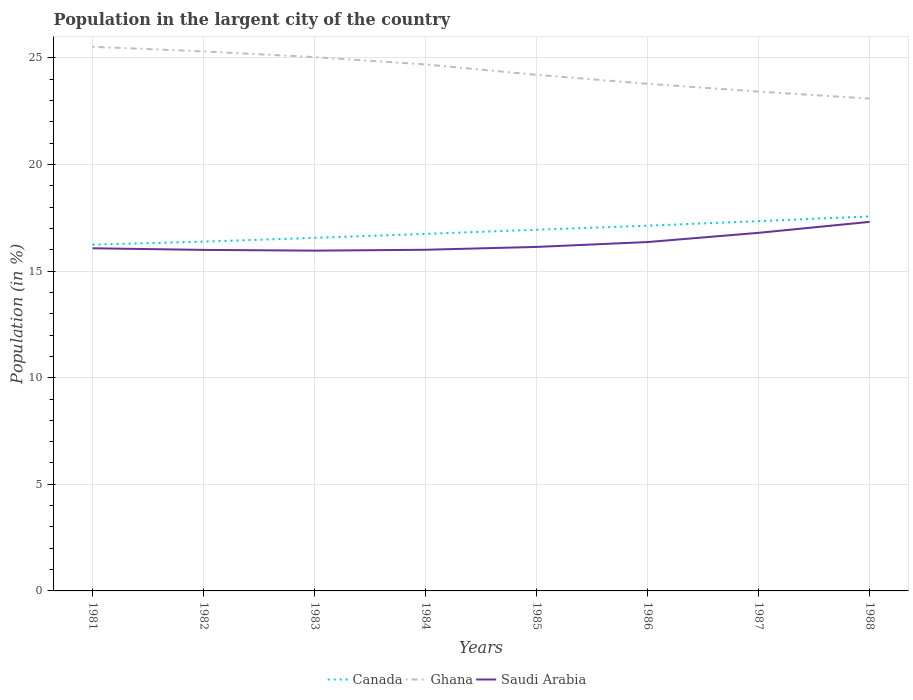Does the line corresponding to Ghana intersect with the line corresponding to Saudi Arabia?
Keep it short and to the point. No. Across all years, what is the maximum percentage of population in the largent city in Canada?
Provide a succinct answer. 16.24. In which year was the percentage of population in the largent city in Saudi Arabia maximum?
Offer a terse response. 1983. What is the total percentage of population in the largent city in Saudi Arabia in the graph?
Provide a short and direct response. -0.17. What is the difference between the highest and the second highest percentage of population in the largent city in Ghana?
Make the answer very short. 2.43. How many lines are there?
Your answer should be very brief. 3. How many years are there in the graph?
Ensure brevity in your answer.  8. What is the difference between two consecutive major ticks on the Y-axis?
Provide a short and direct response. 5. Where does the legend appear in the graph?
Offer a terse response. Bottom center. How are the legend labels stacked?
Offer a terse response. Horizontal. What is the title of the graph?
Offer a terse response. Population in the largent city of the country. Does "Haiti" appear as one of the legend labels in the graph?
Your answer should be compact. No. What is the Population (in %) of Canada in 1981?
Your response must be concise. 16.24. What is the Population (in %) of Ghana in 1981?
Offer a very short reply. 25.52. What is the Population (in %) of Saudi Arabia in 1981?
Offer a terse response. 16.07. What is the Population (in %) of Canada in 1982?
Make the answer very short. 16.38. What is the Population (in %) of Ghana in 1982?
Your answer should be very brief. 25.3. What is the Population (in %) of Saudi Arabia in 1982?
Your answer should be compact. 16. What is the Population (in %) of Canada in 1983?
Make the answer very short. 16.56. What is the Population (in %) in Ghana in 1983?
Provide a short and direct response. 25.04. What is the Population (in %) in Saudi Arabia in 1983?
Your answer should be compact. 15.96. What is the Population (in %) in Canada in 1984?
Your answer should be compact. 16.75. What is the Population (in %) of Ghana in 1984?
Provide a succinct answer. 24.69. What is the Population (in %) of Saudi Arabia in 1984?
Give a very brief answer. 16. What is the Population (in %) of Canada in 1985?
Give a very brief answer. 16.94. What is the Population (in %) of Ghana in 1985?
Your answer should be compact. 24.2. What is the Population (in %) in Saudi Arabia in 1985?
Your answer should be very brief. 16.13. What is the Population (in %) in Canada in 1986?
Offer a terse response. 17.13. What is the Population (in %) of Ghana in 1986?
Give a very brief answer. 23.79. What is the Population (in %) of Saudi Arabia in 1986?
Your response must be concise. 16.36. What is the Population (in %) of Canada in 1987?
Provide a succinct answer. 17.34. What is the Population (in %) in Ghana in 1987?
Your answer should be compact. 23.42. What is the Population (in %) of Saudi Arabia in 1987?
Offer a terse response. 16.8. What is the Population (in %) of Canada in 1988?
Your answer should be compact. 17.56. What is the Population (in %) in Ghana in 1988?
Your answer should be compact. 23.09. What is the Population (in %) in Saudi Arabia in 1988?
Make the answer very short. 17.31. Across all years, what is the maximum Population (in %) of Canada?
Give a very brief answer. 17.56. Across all years, what is the maximum Population (in %) of Ghana?
Offer a very short reply. 25.52. Across all years, what is the maximum Population (in %) of Saudi Arabia?
Your answer should be compact. 17.31. Across all years, what is the minimum Population (in %) in Canada?
Your response must be concise. 16.24. Across all years, what is the minimum Population (in %) in Ghana?
Provide a short and direct response. 23.09. Across all years, what is the minimum Population (in %) in Saudi Arabia?
Offer a terse response. 15.96. What is the total Population (in %) of Canada in the graph?
Offer a terse response. 134.91. What is the total Population (in %) of Ghana in the graph?
Provide a succinct answer. 195.06. What is the total Population (in %) of Saudi Arabia in the graph?
Keep it short and to the point. 130.63. What is the difference between the Population (in %) of Canada in 1981 and that in 1982?
Provide a succinct answer. -0.14. What is the difference between the Population (in %) in Ghana in 1981 and that in 1982?
Ensure brevity in your answer.  0.22. What is the difference between the Population (in %) of Saudi Arabia in 1981 and that in 1982?
Your answer should be very brief. 0.08. What is the difference between the Population (in %) in Canada in 1981 and that in 1983?
Provide a short and direct response. -0.32. What is the difference between the Population (in %) in Ghana in 1981 and that in 1983?
Your response must be concise. 0.49. What is the difference between the Population (in %) of Saudi Arabia in 1981 and that in 1983?
Give a very brief answer. 0.11. What is the difference between the Population (in %) in Canada in 1981 and that in 1984?
Offer a terse response. -0.51. What is the difference between the Population (in %) in Ghana in 1981 and that in 1984?
Make the answer very short. 0.83. What is the difference between the Population (in %) in Saudi Arabia in 1981 and that in 1984?
Provide a short and direct response. 0.07. What is the difference between the Population (in %) of Canada in 1981 and that in 1985?
Provide a succinct answer. -0.7. What is the difference between the Population (in %) in Ghana in 1981 and that in 1985?
Ensure brevity in your answer.  1.32. What is the difference between the Population (in %) of Saudi Arabia in 1981 and that in 1985?
Ensure brevity in your answer.  -0.06. What is the difference between the Population (in %) in Canada in 1981 and that in 1986?
Provide a succinct answer. -0.89. What is the difference between the Population (in %) of Ghana in 1981 and that in 1986?
Offer a terse response. 1.74. What is the difference between the Population (in %) in Saudi Arabia in 1981 and that in 1986?
Your answer should be compact. -0.29. What is the difference between the Population (in %) in Canada in 1981 and that in 1987?
Ensure brevity in your answer.  -1.1. What is the difference between the Population (in %) of Ghana in 1981 and that in 1987?
Keep it short and to the point. 2.1. What is the difference between the Population (in %) in Saudi Arabia in 1981 and that in 1987?
Ensure brevity in your answer.  -0.72. What is the difference between the Population (in %) of Canada in 1981 and that in 1988?
Your answer should be very brief. -1.32. What is the difference between the Population (in %) of Ghana in 1981 and that in 1988?
Your answer should be very brief. 2.43. What is the difference between the Population (in %) of Saudi Arabia in 1981 and that in 1988?
Give a very brief answer. -1.24. What is the difference between the Population (in %) in Canada in 1982 and that in 1983?
Keep it short and to the point. -0.18. What is the difference between the Population (in %) in Ghana in 1982 and that in 1983?
Provide a short and direct response. 0.27. What is the difference between the Population (in %) of Saudi Arabia in 1982 and that in 1983?
Your answer should be very brief. 0.04. What is the difference between the Population (in %) in Canada in 1982 and that in 1984?
Your response must be concise. -0.36. What is the difference between the Population (in %) of Ghana in 1982 and that in 1984?
Your answer should be compact. 0.61. What is the difference between the Population (in %) of Saudi Arabia in 1982 and that in 1984?
Your response must be concise. -0.01. What is the difference between the Population (in %) of Canada in 1982 and that in 1985?
Your response must be concise. -0.56. What is the difference between the Population (in %) in Ghana in 1982 and that in 1985?
Provide a short and direct response. 1.1. What is the difference between the Population (in %) in Saudi Arabia in 1982 and that in 1985?
Ensure brevity in your answer.  -0.14. What is the difference between the Population (in %) in Canada in 1982 and that in 1986?
Provide a short and direct response. -0.75. What is the difference between the Population (in %) in Ghana in 1982 and that in 1986?
Your response must be concise. 1.52. What is the difference between the Population (in %) of Saudi Arabia in 1982 and that in 1986?
Provide a succinct answer. -0.37. What is the difference between the Population (in %) in Canada in 1982 and that in 1987?
Provide a short and direct response. -0.96. What is the difference between the Population (in %) in Ghana in 1982 and that in 1987?
Provide a succinct answer. 1.88. What is the difference between the Population (in %) of Saudi Arabia in 1982 and that in 1987?
Keep it short and to the point. -0.8. What is the difference between the Population (in %) in Canada in 1982 and that in 1988?
Provide a succinct answer. -1.18. What is the difference between the Population (in %) in Ghana in 1982 and that in 1988?
Keep it short and to the point. 2.21. What is the difference between the Population (in %) of Saudi Arabia in 1982 and that in 1988?
Your answer should be very brief. -1.31. What is the difference between the Population (in %) of Canada in 1983 and that in 1984?
Give a very brief answer. -0.19. What is the difference between the Population (in %) of Ghana in 1983 and that in 1984?
Your response must be concise. 0.34. What is the difference between the Population (in %) of Saudi Arabia in 1983 and that in 1984?
Keep it short and to the point. -0.04. What is the difference between the Population (in %) in Canada in 1983 and that in 1985?
Provide a short and direct response. -0.38. What is the difference between the Population (in %) in Ghana in 1983 and that in 1985?
Offer a very short reply. 0.83. What is the difference between the Population (in %) in Saudi Arabia in 1983 and that in 1985?
Offer a terse response. -0.17. What is the difference between the Population (in %) of Canada in 1983 and that in 1986?
Provide a short and direct response. -0.57. What is the difference between the Population (in %) in Ghana in 1983 and that in 1986?
Provide a succinct answer. 1.25. What is the difference between the Population (in %) of Saudi Arabia in 1983 and that in 1986?
Offer a terse response. -0.4. What is the difference between the Population (in %) in Canada in 1983 and that in 1987?
Give a very brief answer. -0.78. What is the difference between the Population (in %) of Ghana in 1983 and that in 1987?
Your response must be concise. 1.62. What is the difference between the Population (in %) of Saudi Arabia in 1983 and that in 1987?
Ensure brevity in your answer.  -0.84. What is the difference between the Population (in %) in Canada in 1983 and that in 1988?
Ensure brevity in your answer.  -1. What is the difference between the Population (in %) of Ghana in 1983 and that in 1988?
Offer a terse response. 1.95. What is the difference between the Population (in %) of Saudi Arabia in 1983 and that in 1988?
Offer a very short reply. -1.35. What is the difference between the Population (in %) in Canada in 1984 and that in 1985?
Provide a short and direct response. -0.19. What is the difference between the Population (in %) in Ghana in 1984 and that in 1985?
Give a very brief answer. 0.49. What is the difference between the Population (in %) of Saudi Arabia in 1984 and that in 1985?
Your answer should be very brief. -0.13. What is the difference between the Population (in %) in Canada in 1984 and that in 1986?
Offer a very short reply. -0.38. What is the difference between the Population (in %) in Ghana in 1984 and that in 1986?
Offer a very short reply. 0.91. What is the difference between the Population (in %) of Saudi Arabia in 1984 and that in 1986?
Provide a short and direct response. -0.36. What is the difference between the Population (in %) in Canada in 1984 and that in 1987?
Your answer should be compact. -0.6. What is the difference between the Population (in %) in Ghana in 1984 and that in 1987?
Make the answer very short. 1.27. What is the difference between the Population (in %) of Saudi Arabia in 1984 and that in 1987?
Provide a succinct answer. -0.79. What is the difference between the Population (in %) of Canada in 1984 and that in 1988?
Ensure brevity in your answer.  -0.82. What is the difference between the Population (in %) in Ghana in 1984 and that in 1988?
Your answer should be compact. 1.6. What is the difference between the Population (in %) of Saudi Arabia in 1984 and that in 1988?
Provide a succinct answer. -1.31. What is the difference between the Population (in %) of Canada in 1985 and that in 1986?
Your response must be concise. -0.19. What is the difference between the Population (in %) of Ghana in 1985 and that in 1986?
Your answer should be compact. 0.42. What is the difference between the Population (in %) of Saudi Arabia in 1985 and that in 1986?
Make the answer very short. -0.23. What is the difference between the Population (in %) in Canada in 1985 and that in 1987?
Make the answer very short. -0.4. What is the difference between the Population (in %) of Ghana in 1985 and that in 1987?
Your answer should be compact. 0.78. What is the difference between the Population (in %) of Saudi Arabia in 1985 and that in 1987?
Offer a terse response. -0.66. What is the difference between the Population (in %) of Canada in 1985 and that in 1988?
Your response must be concise. -0.62. What is the difference between the Population (in %) of Ghana in 1985 and that in 1988?
Offer a very short reply. 1.11. What is the difference between the Population (in %) in Saudi Arabia in 1985 and that in 1988?
Offer a terse response. -1.18. What is the difference between the Population (in %) in Canada in 1986 and that in 1987?
Offer a terse response. -0.21. What is the difference between the Population (in %) in Ghana in 1986 and that in 1987?
Make the answer very short. 0.37. What is the difference between the Population (in %) of Saudi Arabia in 1986 and that in 1987?
Keep it short and to the point. -0.43. What is the difference between the Population (in %) in Canada in 1986 and that in 1988?
Your answer should be compact. -0.43. What is the difference between the Population (in %) in Ghana in 1986 and that in 1988?
Keep it short and to the point. 0.7. What is the difference between the Population (in %) of Saudi Arabia in 1986 and that in 1988?
Your response must be concise. -0.95. What is the difference between the Population (in %) of Canada in 1987 and that in 1988?
Give a very brief answer. -0.22. What is the difference between the Population (in %) in Ghana in 1987 and that in 1988?
Provide a short and direct response. 0.33. What is the difference between the Population (in %) in Saudi Arabia in 1987 and that in 1988?
Your answer should be compact. -0.51. What is the difference between the Population (in %) of Canada in 1981 and the Population (in %) of Ghana in 1982?
Your response must be concise. -9.06. What is the difference between the Population (in %) of Canada in 1981 and the Population (in %) of Saudi Arabia in 1982?
Provide a short and direct response. 0.25. What is the difference between the Population (in %) in Ghana in 1981 and the Population (in %) in Saudi Arabia in 1982?
Give a very brief answer. 9.53. What is the difference between the Population (in %) in Canada in 1981 and the Population (in %) in Ghana in 1983?
Offer a very short reply. -8.8. What is the difference between the Population (in %) of Canada in 1981 and the Population (in %) of Saudi Arabia in 1983?
Make the answer very short. 0.28. What is the difference between the Population (in %) of Ghana in 1981 and the Population (in %) of Saudi Arabia in 1983?
Keep it short and to the point. 9.56. What is the difference between the Population (in %) of Canada in 1981 and the Population (in %) of Ghana in 1984?
Your response must be concise. -8.45. What is the difference between the Population (in %) of Canada in 1981 and the Population (in %) of Saudi Arabia in 1984?
Ensure brevity in your answer.  0.24. What is the difference between the Population (in %) of Ghana in 1981 and the Population (in %) of Saudi Arabia in 1984?
Give a very brief answer. 9.52. What is the difference between the Population (in %) of Canada in 1981 and the Population (in %) of Ghana in 1985?
Offer a terse response. -7.96. What is the difference between the Population (in %) in Canada in 1981 and the Population (in %) in Saudi Arabia in 1985?
Offer a very short reply. 0.11. What is the difference between the Population (in %) of Ghana in 1981 and the Population (in %) of Saudi Arabia in 1985?
Make the answer very short. 9.39. What is the difference between the Population (in %) of Canada in 1981 and the Population (in %) of Ghana in 1986?
Provide a succinct answer. -7.55. What is the difference between the Population (in %) of Canada in 1981 and the Population (in %) of Saudi Arabia in 1986?
Provide a short and direct response. -0.12. What is the difference between the Population (in %) in Ghana in 1981 and the Population (in %) in Saudi Arabia in 1986?
Ensure brevity in your answer.  9.16. What is the difference between the Population (in %) of Canada in 1981 and the Population (in %) of Ghana in 1987?
Give a very brief answer. -7.18. What is the difference between the Population (in %) in Canada in 1981 and the Population (in %) in Saudi Arabia in 1987?
Your answer should be very brief. -0.55. What is the difference between the Population (in %) in Ghana in 1981 and the Population (in %) in Saudi Arabia in 1987?
Your answer should be compact. 8.73. What is the difference between the Population (in %) of Canada in 1981 and the Population (in %) of Ghana in 1988?
Provide a short and direct response. -6.85. What is the difference between the Population (in %) of Canada in 1981 and the Population (in %) of Saudi Arabia in 1988?
Make the answer very short. -1.07. What is the difference between the Population (in %) in Ghana in 1981 and the Population (in %) in Saudi Arabia in 1988?
Offer a very short reply. 8.21. What is the difference between the Population (in %) in Canada in 1982 and the Population (in %) in Ghana in 1983?
Your response must be concise. -8.65. What is the difference between the Population (in %) in Canada in 1982 and the Population (in %) in Saudi Arabia in 1983?
Your response must be concise. 0.42. What is the difference between the Population (in %) of Ghana in 1982 and the Population (in %) of Saudi Arabia in 1983?
Your answer should be compact. 9.34. What is the difference between the Population (in %) of Canada in 1982 and the Population (in %) of Ghana in 1984?
Offer a very short reply. -8.31. What is the difference between the Population (in %) in Canada in 1982 and the Population (in %) in Saudi Arabia in 1984?
Your answer should be compact. 0.38. What is the difference between the Population (in %) in Ghana in 1982 and the Population (in %) in Saudi Arabia in 1984?
Offer a terse response. 9.3. What is the difference between the Population (in %) of Canada in 1982 and the Population (in %) of Ghana in 1985?
Ensure brevity in your answer.  -7.82. What is the difference between the Population (in %) of Canada in 1982 and the Population (in %) of Saudi Arabia in 1985?
Provide a succinct answer. 0.25. What is the difference between the Population (in %) in Ghana in 1982 and the Population (in %) in Saudi Arabia in 1985?
Your response must be concise. 9.17. What is the difference between the Population (in %) in Canada in 1982 and the Population (in %) in Ghana in 1986?
Ensure brevity in your answer.  -7.4. What is the difference between the Population (in %) in Ghana in 1982 and the Population (in %) in Saudi Arabia in 1986?
Make the answer very short. 8.94. What is the difference between the Population (in %) of Canada in 1982 and the Population (in %) of Ghana in 1987?
Provide a short and direct response. -7.04. What is the difference between the Population (in %) in Canada in 1982 and the Population (in %) in Saudi Arabia in 1987?
Give a very brief answer. -0.41. What is the difference between the Population (in %) of Ghana in 1982 and the Population (in %) of Saudi Arabia in 1987?
Give a very brief answer. 8.51. What is the difference between the Population (in %) of Canada in 1982 and the Population (in %) of Ghana in 1988?
Provide a succinct answer. -6.71. What is the difference between the Population (in %) in Canada in 1982 and the Population (in %) in Saudi Arabia in 1988?
Provide a succinct answer. -0.93. What is the difference between the Population (in %) in Ghana in 1982 and the Population (in %) in Saudi Arabia in 1988?
Make the answer very short. 7.99. What is the difference between the Population (in %) of Canada in 1983 and the Population (in %) of Ghana in 1984?
Offer a terse response. -8.13. What is the difference between the Population (in %) in Canada in 1983 and the Population (in %) in Saudi Arabia in 1984?
Your response must be concise. 0.56. What is the difference between the Population (in %) of Ghana in 1983 and the Population (in %) of Saudi Arabia in 1984?
Provide a succinct answer. 9.03. What is the difference between the Population (in %) of Canada in 1983 and the Population (in %) of Ghana in 1985?
Provide a short and direct response. -7.64. What is the difference between the Population (in %) of Canada in 1983 and the Population (in %) of Saudi Arabia in 1985?
Keep it short and to the point. 0.43. What is the difference between the Population (in %) of Ghana in 1983 and the Population (in %) of Saudi Arabia in 1985?
Make the answer very short. 8.9. What is the difference between the Population (in %) of Canada in 1983 and the Population (in %) of Ghana in 1986?
Your answer should be very brief. -7.23. What is the difference between the Population (in %) of Canada in 1983 and the Population (in %) of Saudi Arabia in 1986?
Offer a very short reply. 0.2. What is the difference between the Population (in %) of Ghana in 1983 and the Population (in %) of Saudi Arabia in 1986?
Ensure brevity in your answer.  8.67. What is the difference between the Population (in %) of Canada in 1983 and the Population (in %) of Ghana in 1987?
Your response must be concise. -6.86. What is the difference between the Population (in %) in Canada in 1983 and the Population (in %) in Saudi Arabia in 1987?
Your answer should be compact. -0.24. What is the difference between the Population (in %) in Ghana in 1983 and the Population (in %) in Saudi Arabia in 1987?
Your response must be concise. 8.24. What is the difference between the Population (in %) of Canada in 1983 and the Population (in %) of Ghana in 1988?
Keep it short and to the point. -6.53. What is the difference between the Population (in %) in Canada in 1983 and the Population (in %) in Saudi Arabia in 1988?
Your response must be concise. -0.75. What is the difference between the Population (in %) of Ghana in 1983 and the Population (in %) of Saudi Arabia in 1988?
Your answer should be very brief. 7.73. What is the difference between the Population (in %) in Canada in 1984 and the Population (in %) in Ghana in 1985?
Make the answer very short. -7.46. What is the difference between the Population (in %) of Canada in 1984 and the Population (in %) of Saudi Arabia in 1985?
Offer a very short reply. 0.61. What is the difference between the Population (in %) in Ghana in 1984 and the Population (in %) in Saudi Arabia in 1985?
Provide a short and direct response. 8.56. What is the difference between the Population (in %) in Canada in 1984 and the Population (in %) in Ghana in 1986?
Provide a succinct answer. -7.04. What is the difference between the Population (in %) of Canada in 1984 and the Population (in %) of Saudi Arabia in 1986?
Provide a succinct answer. 0.38. What is the difference between the Population (in %) in Ghana in 1984 and the Population (in %) in Saudi Arabia in 1986?
Offer a terse response. 8.33. What is the difference between the Population (in %) of Canada in 1984 and the Population (in %) of Ghana in 1987?
Provide a short and direct response. -6.67. What is the difference between the Population (in %) in Canada in 1984 and the Population (in %) in Saudi Arabia in 1987?
Make the answer very short. -0.05. What is the difference between the Population (in %) in Ghana in 1984 and the Population (in %) in Saudi Arabia in 1987?
Ensure brevity in your answer.  7.9. What is the difference between the Population (in %) in Canada in 1984 and the Population (in %) in Ghana in 1988?
Make the answer very short. -6.34. What is the difference between the Population (in %) in Canada in 1984 and the Population (in %) in Saudi Arabia in 1988?
Your answer should be compact. -0.56. What is the difference between the Population (in %) in Ghana in 1984 and the Population (in %) in Saudi Arabia in 1988?
Offer a very short reply. 7.38. What is the difference between the Population (in %) in Canada in 1985 and the Population (in %) in Ghana in 1986?
Offer a terse response. -6.85. What is the difference between the Population (in %) in Canada in 1985 and the Population (in %) in Saudi Arabia in 1986?
Provide a succinct answer. 0.58. What is the difference between the Population (in %) of Ghana in 1985 and the Population (in %) of Saudi Arabia in 1986?
Provide a succinct answer. 7.84. What is the difference between the Population (in %) of Canada in 1985 and the Population (in %) of Ghana in 1987?
Provide a short and direct response. -6.48. What is the difference between the Population (in %) in Canada in 1985 and the Population (in %) in Saudi Arabia in 1987?
Your answer should be very brief. 0.14. What is the difference between the Population (in %) of Ghana in 1985 and the Population (in %) of Saudi Arabia in 1987?
Offer a very short reply. 7.41. What is the difference between the Population (in %) in Canada in 1985 and the Population (in %) in Ghana in 1988?
Provide a short and direct response. -6.15. What is the difference between the Population (in %) in Canada in 1985 and the Population (in %) in Saudi Arabia in 1988?
Provide a short and direct response. -0.37. What is the difference between the Population (in %) in Ghana in 1985 and the Population (in %) in Saudi Arabia in 1988?
Offer a very short reply. 6.89. What is the difference between the Population (in %) in Canada in 1986 and the Population (in %) in Ghana in 1987?
Your answer should be compact. -6.29. What is the difference between the Population (in %) of Canada in 1986 and the Population (in %) of Saudi Arabia in 1987?
Make the answer very short. 0.33. What is the difference between the Population (in %) of Ghana in 1986 and the Population (in %) of Saudi Arabia in 1987?
Offer a terse response. 6.99. What is the difference between the Population (in %) in Canada in 1986 and the Population (in %) in Ghana in 1988?
Offer a very short reply. -5.96. What is the difference between the Population (in %) in Canada in 1986 and the Population (in %) in Saudi Arabia in 1988?
Give a very brief answer. -0.18. What is the difference between the Population (in %) of Ghana in 1986 and the Population (in %) of Saudi Arabia in 1988?
Ensure brevity in your answer.  6.48. What is the difference between the Population (in %) of Canada in 1987 and the Population (in %) of Ghana in 1988?
Keep it short and to the point. -5.75. What is the difference between the Population (in %) in Canada in 1987 and the Population (in %) in Saudi Arabia in 1988?
Offer a terse response. 0.03. What is the difference between the Population (in %) of Ghana in 1987 and the Population (in %) of Saudi Arabia in 1988?
Ensure brevity in your answer.  6.11. What is the average Population (in %) in Canada per year?
Your response must be concise. 16.86. What is the average Population (in %) in Ghana per year?
Your answer should be compact. 24.38. What is the average Population (in %) in Saudi Arabia per year?
Give a very brief answer. 16.33. In the year 1981, what is the difference between the Population (in %) in Canada and Population (in %) in Ghana?
Offer a very short reply. -9.28. In the year 1981, what is the difference between the Population (in %) in Canada and Population (in %) in Saudi Arabia?
Make the answer very short. 0.17. In the year 1981, what is the difference between the Population (in %) of Ghana and Population (in %) of Saudi Arabia?
Keep it short and to the point. 9.45. In the year 1982, what is the difference between the Population (in %) of Canada and Population (in %) of Ghana?
Make the answer very short. -8.92. In the year 1982, what is the difference between the Population (in %) of Canada and Population (in %) of Saudi Arabia?
Offer a terse response. 0.39. In the year 1982, what is the difference between the Population (in %) in Ghana and Population (in %) in Saudi Arabia?
Provide a succinct answer. 9.31. In the year 1983, what is the difference between the Population (in %) in Canada and Population (in %) in Ghana?
Keep it short and to the point. -8.48. In the year 1983, what is the difference between the Population (in %) in Canada and Population (in %) in Saudi Arabia?
Provide a succinct answer. 0.6. In the year 1983, what is the difference between the Population (in %) of Ghana and Population (in %) of Saudi Arabia?
Your answer should be compact. 9.08. In the year 1984, what is the difference between the Population (in %) of Canada and Population (in %) of Ghana?
Give a very brief answer. -7.95. In the year 1984, what is the difference between the Population (in %) in Canada and Population (in %) in Saudi Arabia?
Give a very brief answer. 0.75. In the year 1984, what is the difference between the Population (in %) of Ghana and Population (in %) of Saudi Arabia?
Provide a short and direct response. 8.69. In the year 1985, what is the difference between the Population (in %) of Canada and Population (in %) of Ghana?
Offer a terse response. -7.26. In the year 1985, what is the difference between the Population (in %) of Canada and Population (in %) of Saudi Arabia?
Your response must be concise. 0.81. In the year 1985, what is the difference between the Population (in %) in Ghana and Population (in %) in Saudi Arabia?
Give a very brief answer. 8.07. In the year 1986, what is the difference between the Population (in %) of Canada and Population (in %) of Ghana?
Give a very brief answer. -6.66. In the year 1986, what is the difference between the Population (in %) of Canada and Population (in %) of Saudi Arabia?
Your response must be concise. 0.77. In the year 1986, what is the difference between the Population (in %) in Ghana and Population (in %) in Saudi Arabia?
Give a very brief answer. 7.42. In the year 1987, what is the difference between the Population (in %) of Canada and Population (in %) of Ghana?
Your answer should be very brief. -6.08. In the year 1987, what is the difference between the Population (in %) in Canada and Population (in %) in Saudi Arabia?
Offer a very short reply. 0.55. In the year 1987, what is the difference between the Population (in %) in Ghana and Population (in %) in Saudi Arabia?
Offer a terse response. 6.62. In the year 1988, what is the difference between the Population (in %) of Canada and Population (in %) of Ghana?
Provide a succinct answer. -5.53. In the year 1988, what is the difference between the Population (in %) in Canada and Population (in %) in Saudi Arabia?
Your answer should be compact. 0.25. In the year 1988, what is the difference between the Population (in %) in Ghana and Population (in %) in Saudi Arabia?
Ensure brevity in your answer.  5.78. What is the ratio of the Population (in %) in Canada in 1981 to that in 1982?
Give a very brief answer. 0.99. What is the ratio of the Population (in %) of Ghana in 1981 to that in 1982?
Give a very brief answer. 1.01. What is the ratio of the Population (in %) in Canada in 1981 to that in 1983?
Offer a very short reply. 0.98. What is the ratio of the Population (in %) of Ghana in 1981 to that in 1983?
Give a very brief answer. 1.02. What is the ratio of the Population (in %) in Saudi Arabia in 1981 to that in 1983?
Offer a very short reply. 1.01. What is the ratio of the Population (in %) of Canada in 1981 to that in 1984?
Provide a short and direct response. 0.97. What is the ratio of the Population (in %) in Ghana in 1981 to that in 1984?
Provide a short and direct response. 1.03. What is the ratio of the Population (in %) of Saudi Arabia in 1981 to that in 1984?
Your response must be concise. 1. What is the ratio of the Population (in %) of Canada in 1981 to that in 1985?
Provide a short and direct response. 0.96. What is the ratio of the Population (in %) of Ghana in 1981 to that in 1985?
Provide a short and direct response. 1.05. What is the ratio of the Population (in %) of Canada in 1981 to that in 1986?
Give a very brief answer. 0.95. What is the ratio of the Population (in %) in Ghana in 1981 to that in 1986?
Provide a short and direct response. 1.07. What is the ratio of the Population (in %) of Saudi Arabia in 1981 to that in 1986?
Your response must be concise. 0.98. What is the ratio of the Population (in %) in Canada in 1981 to that in 1987?
Make the answer very short. 0.94. What is the ratio of the Population (in %) in Ghana in 1981 to that in 1987?
Keep it short and to the point. 1.09. What is the ratio of the Population (in %) in Saudi Arabia in 1981 to that in 1987?
Offer a terse response. 0.96. What is the ratio of the Population (in %) in Canada in 1981 to that in 1988?
Provide a succinct answer. 0.92. What is the ratio of the Population (in %) of Ghana in 1981 to that in 1988?
Provide a succinct answer. 1.11. What is the ratio of the Population (in %) of Saudi Arabia in 1981 to that in 1988?
Provide a short and direct response. 0.93. What is the ratio of the Population (in %) in Canada in 1982 to that in 1983?
Make the answer very short. 0.99. What is the ratio of the Population (in %) of Ghana in 1982 to that in 1983?
Provide a short and direct response. 1.01. What is the ratio of the Population (in %) in Saudi Arabia in 1982 to that in 1983?
Your response must be concise. 1. What is the ratio of the Population (in %) of Canada in 1982 to that in 1984?
Your answer should be very brief. 0.98. What is the ratio of the Population (in %) of Ghana in 1982 to that in 1984?
Make the answer very short. 1.02. What is the ratio of the Population (in %) of Saudi Arabia in 1982 to that in 1984?
Ensure brevity in your answer.  1. What is the ratio of the Population (in %) in Canada in 1982 to that in 1985?
Keep it short and to the point. 0.97. What is the ratio of the Population (in %) in Ghana in 1982 to that in 1985?
Your answer should be compact. 1.05. What is the ratio of the Population (in %) of Saudi Arabia in 1982 to that in 1985?
Keep it short and to the point. 0.99. What is the ratio of the Population (in %) of Canada in 1982 to that in 1986?
Give a very brief answer. 0.96. What is the ratio of the Population (in %) in Ghana in 1982 to that in 1986?
Your response must be concise. 1.06. What is the ratio of the Population (in %) of Saudi Arabia in 1982 to that in 1986?
Offer a terse response. 0.98. What is the ratio of the Population (in %) of Canada in 1982 to that in 1987?
Your answer should be compact. 0.94. What is the ratio of the Population (in %) of Ghana in 1982 to that in 1987?
Your answer should be very brief. 1.08. What is the ratio of the Population (in %) in Saudi Arabia in 1982 to that in 1987?
Your answer should be very brief. 0.95. What is the ratio of the Population (in %) in Canada in 1982 to that in 1988?
Provide a short and direct response. 0.93. What is the ratio of the Population (in %) in Ghana in 1982 to that in 1988?
Make the answer very short. 1.1. What is the ratio of the Population (in %) in Saudi Arabia in 1982 to that in 1988?
Your answer should be very brief. 0.92. What is the ratio of the Population (in %) of Ghana in 1983 to that in 1984?
Make the answer very short. 1.01. What is the ratio of the Population (in %) in Canada in 1983 to that in 1985?
Keep it short and to the point. 0.98. What is the ratio of the Population (in %) in Ghana in 1983 to that in 1985?
Offer a terse response. 1.03. What is the ratio of the Population (in %) of Canada in 1983 to that in 1986?
Offer a terse response. 0.97. What is the ratio of the Population (in %) in Ghana in 1983 to that in 1986?
Provide a succinct answer. 1.05. What is the ratio of the Population (in %) in Saudi Arabia in 1983 to that in 1986?
Give a very brief answer. 0.98. What is the ratio of the Population (in %) in Canada in 1983 to that in 1987?
Provide a short and direct response. 0.95. What is the ratio of the Population (in %) in Ghana in 1983 to that in 1987?
Ensure brevity in your answer.  1.07. What is the ratio of the Population (in %) of Saudi Arabia in 1983 to that in 1987?
Ensure brevity in your answer.  0.95. What is the ratio of the Population (in %) in Canada in 1983 to that in 1988?
Keep it short and to the point. 0.94. What is the ratio of the Population (in %) in Ghana in 1983 to that in 1988?
Offer a very short reply. 1.08. What is the ratio of the Population (in %) of Saudi Arabia in 1983 to that in 1988?
Your answer should be very brief. 0.92. What is the ratio of the Population (in %) of Ghana in 1984 to that in 1985?
Offer a very short reply. 1.02. What is the ratio of the Population (in %) of Canada in 1984 to that in 1986?
Provide a succinct answer. 0.98. What is the ratio of the Population (in %) in Ghana in 1984 to that in 1986?
Provide a succinct answer. 1.04. What is the ratio of the Population (in %) in Saudi Arabia in 1984 to that in 1986?
Offer a terse response. 0.98. What is the ratio of the Population (in %) of Canada in 1984 to that in 1987?
Give a very brief answer. 0.97. What is the ratio of the Population (in %) in Ghana in 1984 to that in 1987?
Offer a terse response. 1.05. What is the ratio of the Population (in %) of Saudi Arabia in 1984 to that in 1987?
Your answer should be very brief. 0.95. What is the ratio of the Population (in %) of Canada in 1984 to that in 1988?
Your answer should be compact. 0.95. What is the ratio of the Population (in %) of Ghana in 1984 to that in 1988?
Provide a short and direct response. 1.07. What is the ratio of the Population (in %) in Saudi Arabia in 1984 to that in 1988?
Your response must be concise. 0.92. What is the ratio of the Population (in %) of Canada in 1985 to that in 1986?
Provide a succinct answer. 0.99. What is the ratio of the Population (in %) of Ghana in 1985 to that in 1986?
Your answer should be compact. 1.02. What is the ratio of the Population (in %) in Saudi Arabia in 1985 to that in 1986?
Give a very brief answer. 0.99. What is the ratio of the Population (in %) of Canada in 1985 to that in 1987?
Make the answer very short. 0.98. What is the ratio of the Population (in %) of Ghana in 1985 to that in 1987?
Your answer should be compact. 1.03. What is the ratio of the Population (in %) of Saudi Arabia in 1985 to that in 1987?
Provide a succinct answer. 0.96. What is the ratio of the Population (in %) in Canada in 1985 to that in 1988?
Provide a short and direct response. 0.96. What is the ratio of the Population (in %) of Ghana in 1985 to that in 1988?
Give a very brief answer. 1.05. What is the ratio of the Population (in %) of Saudi Arabia in 1985 to that in 1988?
Ensure brevity in your answer.  0.93. What is the ratio of the Population (in %) of Ghana in 1986 to that in 1987?
Make the answer very short. 1.02. What is the ratio of the Population (in %) in Saudi Arabia in 1986 to that in 1987?
Your answer should be very brief. 0.97. What is the ratio of the Population (in %) in Canada in 1986 to that in 1988?
Give a very brief answer. 0.98. What is the ratio of the Population (in %) of Ghana in 1986 to that in 1988?
Offer a very short reply. 1.03. What is the ratio of the Population (in %) in Saudi Arabia in 1986 to that in 1988?
Provide a succinct answer. 0.95. What is the ratio of the Population (in %) in Canada in 1987 to that in 1988?
Provide a short and direct response. 0.99. What is the ratio of the Population (in %) of Ghana in 1987 to that in 1988?
Your answer should be compact. 1.01. What is the ratio of the Population (in %) in Saudi Arabia in 1987 to that in 1988?
Keep it short and to the point. 0.97. What is the difference between the highest and the second highest Population (in %) of Canada?
Your response must be concise. 0.22. What is the difference between the highest and the second highest Population (in %) of Ghana?
Your response must be concise. 0.22. What is the difference between the highest and the second highest Population (in %) of Saudi Arabia?
Keep it short and to the point. 0.51. What is the difference between the highest and the lowest Population (in %) in Canada?
Offer a terse response. 1.32. What is the difference between the highest and the lowest Population (in %) of Ghana?
Offer a terse response. 2.43. What is the difference between the highest and the lowest Population (in %) of Saudi Arabia?
Provide a succinct answer. 1.35. 